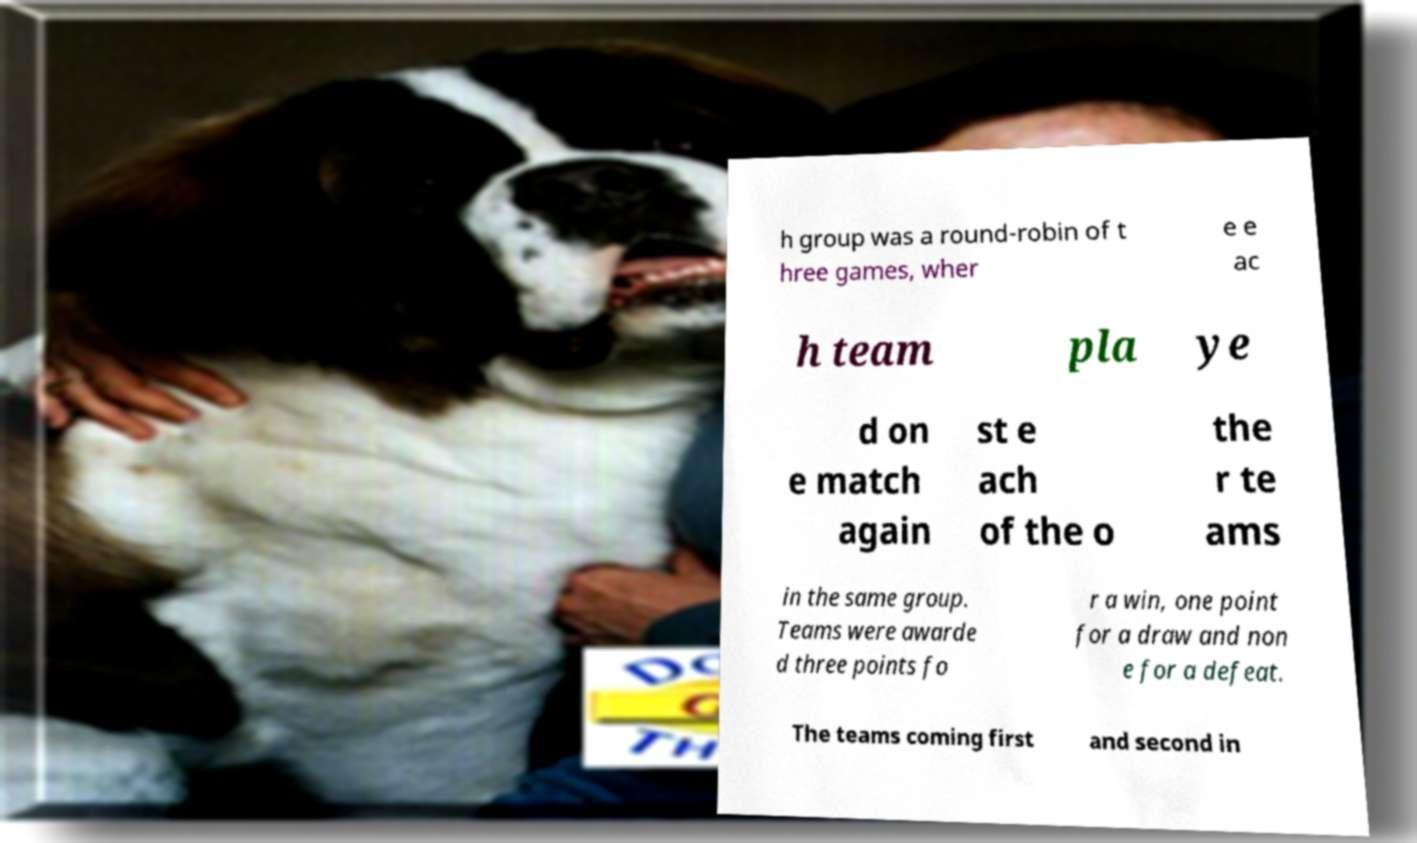Can you read and provide the text displayed in the image?This photo seems to have some interesting text. Can you extract and type it out for me? h group was a round-robin of t hree games, wher e e ac h team pla ye d on e match again st e ach of the o the r te ams in the same group. Teams were awarde d three points fo r a win, one point for a draw and non e for a defeat. The teams coming first and second in 